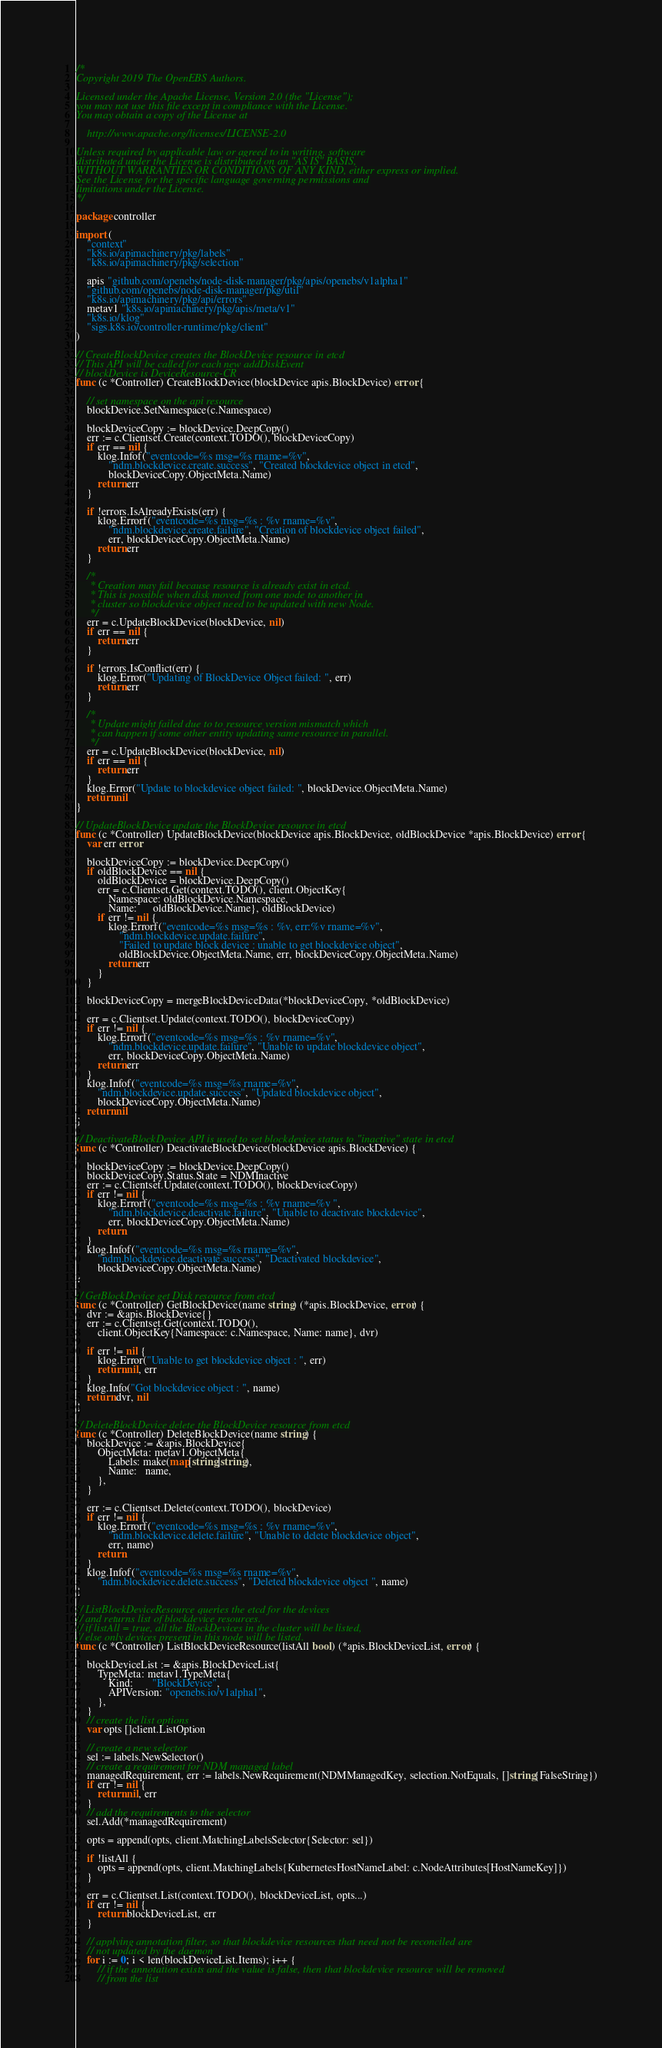Convert code to text. <code><loc_0><loc_0><loc_500><loc_500><_Go_>/*
Copyright 2019 The OpenEBS Authors.

Licensed under the Apache License, Version 2.0 (the "License");
you may not use this file except in compliance with the License.
You may obtain a copy of the License at

    http://www.apache.org/licenses/LICENSE-2.0

Unless required by applicable law or agreed to in writing, software
distributed under the License is distributed on an "AS IS" BASIS,
WITHOUT WARRANTIES OR CONDITIONS OF ANY KIND, either express or implied.
See the License for the specific language governing permissions and
limitations under the License.
*/

package controller

import (
	"context"
	"k8s.io/apimachinery/pkg/labels"
	"k8s.io/apimachinery/pkg/selection"

	apis "github.com/openebs/node-disk-manager/pkg/apis/openebs/v1alpha1"
	"github.com/openebs/node-disk-manager/pkg/util"
	"k8s.io/apimachinery/pkg/api/errors"
	metav1 "k8s.io/apimachinery/pkg/apis/meta/v1"
	"k8s.io/klog"
	"sigs.k8s.io/controller-runtime/pkg/client"
)

// CreateBlockDevice creates the BlockDevice resource in etcd
// This API will be called for each new addDiskEvent
// blockDevice is DeviceResource-CR
func (c *Controller) CreateBlockDevice(blockDevice apis.BlockDevice) error {

	// set namespace on the api resource
	blockDevice.SetNamespace(c.Namespace)

	blockDeviceCopy := blockDevice.DeepCopy()
	err := c.Clientset.Create(context.TODO(), blockDeviceCopy)
	if err == nil {
		klog.Infof("eventcode=%s msg=%s rname=%v",
			"ndm.blockdevice.create.success", "Created blockdevice object in etcd",
			blockDeviceCopy.ObjectMeta.Name)
		return err
	}

	if !errors.IsAlreadyExists(err) {
		klog.Errorf("eventcode=%s msg=%s : %v rname=%v",
			"ndm.blockdevice.create.failure", "Creation of blockdevice object failed",
			err, blockDeviceCopy.ObjectMeta.Name)
		return err
	}

	/*
	 * Creation may fail because resource is already exist in etcd.
	 * This is possible when disk moved from one node to another in
	 * cluster so blockdevice object need to be updated with new Node.
	 */
	err = c.UpdateBlockDevice(blockDevice, nil)
	if err == nil {
		return err
	}

	if !errors.IsConflict(err) {
		klog.Error("Updating of BlockDevice Object failed: ", err)
		return err
	}

	/*
	 * Update might failed due to to resource version mismatch which
	 * can happen if some other entity updating same resource in parallel.
	 */
	err = c.UpdateBlockDevice(blockDevice, nil)
	if err == nil {
		return err
	}
	klog.Error("Update to blockdevice object failed: ", blockDevice.ObjectMeta.Name)
	return nil
}

// UpdateBlockDevice update the BlockDevice resource in etcd
func (c *Controller) UpdateBlockDevice(blockDevice apis.BlockDevice, oldBlockDevice *apis.BlockDevice) error {
	var err error

	blockDeviceCopy := blockDevice.DeepCopy()
	if oldBlockDevice == nil {
		oldBlockDevice = blockDevice.DeepCopy()
		err = c.Clientset.Get(context.TODO(), client.ObjectKey{
			Namespace: oldBlockDevice.Namespace,
			Name:      oldBlockDevice.Name}, oldBlockDevice)
		if err != nil {
			klog.Errorf("eventcode=%s msg=%s : %v, err:%v rname=%v",
				"ndm.blockdevice.update.failure",
				"Failed to update block device : unable to get blockdevice object",
				oldBlockDevice.ObjectMeta.Name, err, blockDeviceCopy.ObjectMeta.Name)
			return err
		}
	}

	blockDeviceCopy = mergeBlockDeviceData(*blockDeviceCopy, *oldBlockDevice)

	err = c.Clientset.Update(context.TODO(), blockDeviceCopy)
	if err != nil {
		klog.Errorf("eventcode=%s msg=%s : %v rname=%v",
			"ndm.blockdevice.update.failure", "Unable to update blockdevice object",
			err, blockDeviceCopy.ObjectMeta.Name)
		return err
	}
	klog.Infof("eventcode=%s msg=%s rname=%v",
		"ndm.blockdevice.update.success", "Updated blockdevice object",
		blockDeviceCopy.ObjectMeta.Name)
	return nil
}

// DeactivateBlockDevice API is used to set blockdevice status to "inactive" state in etcd
func (c *Controller) DeactivateBlockDevice(blockDevice apis.BlockDevice) {

	blockDeviceCopy := blockDevice.DeepCopy()
	blockDeviceCopy.Status.State = NDMInactive
	err := c.Clientset.Update(context.TODO(), blockDeviceCopy)
	if err != nil {
		klog.Errorf("eventcode=%s msg=%s : %v rname=%v ",
			"ndm.blockdevice.deactivate.failure", "Unable to deactivate blockdevice",
			err, blockDeviceCopy.ObjectMeta.Name)
		return
	}
	klog.Infof("eventcode=%s msg=%s rname=%v",
		"ndm.blockdevice.deactivate.success", "Deactivated blockdevice",
		blockDeviceCopy.ObjectMeta.Name)
}

// GetBlockDevice get Disk resource from etcd
func (c *Controller) GetBlockDevice(name string) (*apis.BlockDevice, error) {
	dvr := &apis.BlockDevice{}
	err := c.Clientset.Get(context.TODO(),
		client.ObjectKey{Namespace: c.Namespace, Name: name}, dvr)

	if err != nil {
		klog.Error("Unable to get blockdevice object : ", err)
		return nil, err
	}
	klog.Info("Got blockdevice object : ", name)
	return dvr, nil
}

// DeleteBlockDevice delete the BlockDevice resource from etcd
func (c *Controller) DeleteBlockDevice(name string) {
	blockDevice := &apis.BlockDevice{
		ObjectMeta: metav1.ObjectMeta{
			Labels: make(map[string]string),
			Name:   name,
		},
	}

	err := c.Clientset.Delete(context.TODO(), blockDevice)
	if err != nil {
		klog.Errorf("eventcode=%s msg=%s : %v rname=%v",
			"ndm.blockdevice.delete.failure", "Unable to delete blockdevice object",
			err, name)
		return
	}
	klog.Infof("eventcode=%s msg=%s rname=%v",
		"ndm.blockdevice.delete.success", "Deleted blockdevice object ", name)
}

// ListBlockDeviceResource queries the etcd for the devices
// and returns list of blockdevice resources.
// if listAll = true, all the BlockDevices in the cluster will be listed,
// else only devices present in this node will be listed.
func (c *Controller) ListBlockDeviceResource(listAll bool) (*apis.BlockDeviceList, error) {

	blockDeviceList := &apis.BlockDeviceList{
		TypeMeta: metav1.TypeMeta{
			Kind:       "BlockDevice",
			APIVersion: "openebs.io/v1alpha1",
		},
	}
	// create the list options
	var opts []client.ListOption

	// create a new selector
	sel := labels.NewSelector()
	// create a requirement for NDM managed label
	managedRequirement, err := labels.NewRequirement(NDMManagedKey, selection.NotEquals, []string{FalseString})
	if err != nil {
		return nil, err
	}
	// add the requirements to the selector
	sel.Add(*managedRequirement)

	opts = append(opts, client.MatchingLabelsSelector{Selector: sel})

	if !listAll {
		opts = append(opts, client.MatchingLabels{KubernetesHostNameLabel: c.NodeAttributes[HostNameKey]})
	}

	err = c.Clientset.List(context.TODO(), blockDeviceList, opts...)
	if err != nil {
		return blockDeviceList, err
	}

	// applying annotation filter, so that blockdevice resources that need not be reconciled are
	// not updated by the daemon
	for i := 0; i < len(blockDeviceList.Items); i++ {
		// if the annotation exists and the value is false, then that blockdevice resource will be removed
		// from the list</code> 